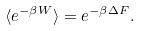<formula> <loc_0><loc_0><loc_500><loc_500>\langle e ^ { - \beta W } \rangle = e ^ { - \beta \Delta F } .</formula> 